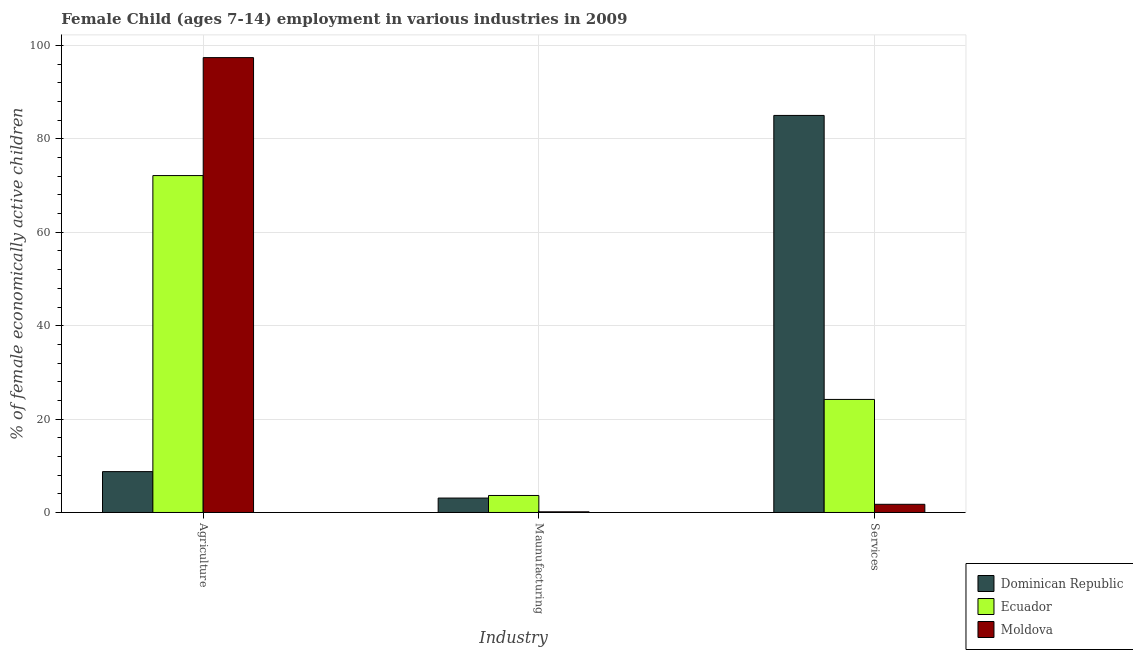How many different coloured bars are there?
Keep it short and to the point. 3. How many groups of bars are there?
Ensure brevity in your answer.  3. Are the number of bars per tick equal to the number of legend labels?
Your response must be concise. Yes. Are the number of bars on each tick of the X-axis equal?
Ensure brevity in your answer.  Yes. How many bars are there on the 3rd tick from the left?
Keep it short and to the point. 3. What is the label of the 2nd group of bars from the left?
Offer a terse response. Maunufacturing. What is the percentage of economically active children in services in Ecuador?
Offer a terse response. 24.21. Across all countries, what is the maximum percentage of economically active children in services?
Give a very brief answer. 85.03. Across all countries, what is the minimum percentage of economically active children in services?
Keep it short and to the point. 1.75. In which country was the percentage of economically active children in services maximum?
Give a very brief answer. Dominican Republic. In which country was the percentage of economically active children in services minimum?
Keep it short and to the point. Moldova. What is the total percentage of economically active children in manufacturing in the graph?
Make the answer very short. 6.87. What is the difference between the percentage of economically active children in agriculture in Ecuador and that in Moldova?
Your response must be concise. -25.26. What is the difference between the percentage of economically active children in services in Moldova and the percentage of economically active children in manufacturing in Dominican Republic?
Provide a succinct answer. -1.34. What is the average percentage of economically active children in services per country?
Your answer should be very brief. 37. What is the difference between the percentage of economically active children in services and percentage of economically active children in agriculture in Dominican Republic?
Your answer should be compact. 76.28. What is the ratio of the percentage of economically active children in services in Moldova to that in Dominican Republic?
Your response must be concise. 0.02. What is the difference between the highest and the second highest percentage of economically active children in agriculture?
Your answer should be very brief. 25.26. What is the difference between the highest and the lowest percentage of economically active children in services?
Your answer should be very brief. 83.28. What does the 3rd bar from the left in Services represents?
Your answer should be very brief. Moldova. What does the 2nd bar from the right in Services represents?
Your answer should be compact. Ecuador. Is it the case that in every country, the sum of the percentage of economically active children in agriculture and percentage of economically active children in manufacturing is greater than the percentage of economically active children in services?
Your answer should be very brief. No. Are all the bars in the graph horizontal?
Your response must be concise. No. How many countries are there in the graph?
Offer a very short reply. 3. What is the difference between two consecutive major ticks on the Y-axis?
Provide a short and direct response. 20. Are the values on the major ticks of Y-axis written in scientific E-notation?
Make the answer very short. No. Does the graph contain grids?
Make the answer very short. Yes. Where does the legend appear in the graph?
Provide a short and direct response. Bottom right. How many legend labels are there?
Keep it short and to the point. 3. What is the title of the graph?
Offer a very short reply. Female Child (ages 7-14) employment in various industries in 2009. What is the label or title of the X-axis?
Offer a very short reply. Industry. What is the label or title of the Y-axis?
Offer a very short reply. % of female economically active children. What is the % of female economically active children in Dominican Republic in Agriculture?
Make the answer very short. 8.75. What is the % of female economically active children of Ecuador in Agriculture?
Your answer should be very brief. 72.15. What is the % of female economically active children in Moldova in Agriculture?
Your response must be concise. 97.41. What is the % of female economically active children in Dominican Republic in Maunufacturing?
Keep it short and to the point. 3.09. What is the % of female economically active children of Ecuador in Maunufacturing?
Your answer should be very brief. 3.64. What is the % of female economically active children in Moldova in Maunufacturing?
Provide a short and direct response. 0.14. What is the % of female economically active children in Dominican Republic in Services?
Ensure brevity in your answer.  85.03. What is the % of female economically active children of Ecuador in Services?
Give a very brief answer. 24.21. Across all Industry, what is the maximum % of female economically active children of Dominican Republic?
Your answer should be very brief. 85.03. Across all Industry, what is the maximum % of female economically active children of Ecuador?
Your answer should be very brief. 72.15. Across all Industry, what is the maximum % of female economically active children in Moldova?
Give a very brief answer. 97.41. Across all Industry, what is the minimum % of female economically active children of Dominican Republic?
Your answer should be very brief. 3.09. Across all Industry, what is the minimum % of female economically active children in Ecuador?
Provide a succinct answer. 3.64. Across all Industry, what is the minimum % of female economically active children of Moldova?
Keep it short and to the point. 0.14. What is the total % of female economically active children of Dominican Republic in the graph?
Your answer should be very brief. 96.87. What is the total % of female economically active children in Moldova in the graph?
Your answer should be compact. 99.3. What is the difference between the % of female economically active children in Dominican Republic in Agriculture and that in Maunufacturing?
Your answer should be compact. 5.66. What is the difference between the % of female economically active children in Ecuador in Agriculture and that in Maunufacturing?
Your answer should be very brief. 68.51. What is the difference between the % of female economically active children in Moldova in Agriculture and that in Maunufacturing?
Your answer should be compact. 97.27. What is the difference between the % of female economically active children in Dominican Republic in Agriculture and that in Services?
Make the answer very short. -76.28. What is the difference between the % of female economically active children in Ecuador in Agriculture and that in Services?
Keep it short and to the point. 47.94. What is the difference between the % of female economically active children in Moldova in Agriculture and that in Services?
Your response must be concise. 95.66. What is the difference between the % of female economically active children in Dominican Republic in Maunufacturing and that in Services?
Your answer should be compact. -81.94. What is the difference between the % of female economically active children in Ecuador in Maunufacturing and that in Services?
Your answer should be compact. -20.57. What is the difference between the % of female economically active children in Moldova in Maunufacturing and that in Services?
Offer a very short reply. -1.61. What is the difference between the % of female economically active children of Dominican Republic in Agriculture and the % of female economically active children of Ecuador in Maunufacturing?
Offer a terse response. 5.11. What is the difference between the % of female economically active children of Dominican Republic in Agriculture and the % of female economically active children of Moldova in Maunufacturing?
Keep it short and to the point. 8.61. What is the difference between the % of female economically active children of Ecuador in Agriculture and the % of female economically active children of Moldova in Maunufacturing?
Your answer should be very brief. 72.01. What is the difference between the % of female economically active children of Dominican Republic in Agriculture and the % of female economically active children of Ecuador in Services?
Your response must be concise. -15.46. What is the difference between the % of female economically active children of Ecuador in Agriculture and the % of female economically active children of Moldova in Services?
Your answer should be very brief. 70.4. What is the difference between the % of female economically active children of Dominican Republic in Maunufacturing and the % of female economically active children of Ecuador in Services?
Your answer should be very brief. -21.12. What is the difference between the % of female economically active children in Dominican Republic in Maunufacturing and the % of female economically active children in Moldova in Services?
Make the answer very short. 1.34. What is the difference between the % of female economically active children of Ecuador in Maunufacturing and the % of female economically active children of Moldova in Services?
Provide a short and direct response. 1.89. What is the average % of female economically active children of Dominican Republic per Industry?
Keep it short and to the point. 32.29. What is the average % of female economically active children in Ecuador per Industry?
Give a very brief answer. 33.33. What is the average % of female economically active children in Moldova per Industry?
Keep it short and to the point. 33.1. What is the difference between the % of female economically active children in Dominican Republic and % of female economically active children in Ecuador in Agriculture?
Ensure brevity in your answer.  -63.4. What is the difference between the % of female economically active children in Dominican Republic and % of female economically active children in Moldova in Agriculture?
Ensure brevity in your answer.  -88.66. What is the difference between the % of female economically active children in Ecuador and % of female economically active children in Moldova in Agriculture?
Your response must be concise. -25.26. What is the difference between the % of female economically active children of Dominican Republic and % of female economically active children of Ecuador in Maunufacturing?
Offer a very short reply. -0.55. What is the difference between the % of female economically active children of Dominican Republic and % of female economically active children of Moldova in Maunufacturing?
Your answer should be very brief. 2.95. What is the difference between the % of female economically active children of Dominican Republic and % of female economically active children of Ecuador in Services?
Offer a very short reply. 60.82. What is the difference between the % of female economically active children of Dominican Republic and % of female economically active children of Moldova in Services?
Ensure brevity in your answer.  83.28. What is the difference between the % of female economically active children of Ecuador and % of female economically active children of Moldova in Services?
Provide a succinct answer. 22.46. What is the ratio of the % of female economically active children in Dominican Republic in Agriculture to that in Maunufacturing?
Ensure brevity in your answer.  2.83. What is the ratio of the % of female economically active children of Ecuador in Agriculture to that in Maunufacturing?
Your response must be concise. 19.82. What is the ratio of the % of female economically active children in Moldova in Agriculture to that in Maunufacturing?
Your answer should be compact. 695.79. What is the ratio of the % of female economically active children of Dominican Republic in Agriculture to that in Services?
Ensure brevity in your answer.  0.1. What is the ratio of the % of female economically active children in Ecuador in Agriculture to that in Services?
Offer a terse response. 2.98. What is the ratio of the % of female economically active children in Moldova in Agriculture to that in Services?
Make the answer very short. 55.66. What is the ratio of the % of female economically active children of Dominican Republic in Maunufacturing to that in Services?
Provide a succinct answer. 0.04. What is the ratio of the % of female economically active children in Ecuador in Maunufacturing to that in Services?
Offer a very short reply. 0.15. What is the ratio of the % of female economically active children of Moldova in Maunufacturing to that in Services?
Your answer should be compact. 0.08. What is the difference between the highest and the second highest % of female economically active children of Dominican Republic?
Offer a very short reply. 76.28. What is the difference between the highest and the second highest % of female economically active children in Ecuador?
Give a very brief answer. 47.94. What is the difference between the highest and the second highest % of female economically active children in Moldova?
Make the answer very short. 95.66. What is the difference between the highest and the lowest % of female economically active children in Dominican Republic?
Provide a succinct answer. 81.94. What is the difference between the highest and the lowest % of female economically active children of Ecuador?
Your response must be concise. 68.51. What is the difference between the highest and the lowest % of female economically active children in Moldova?
Your response must be concise. 97.27. 